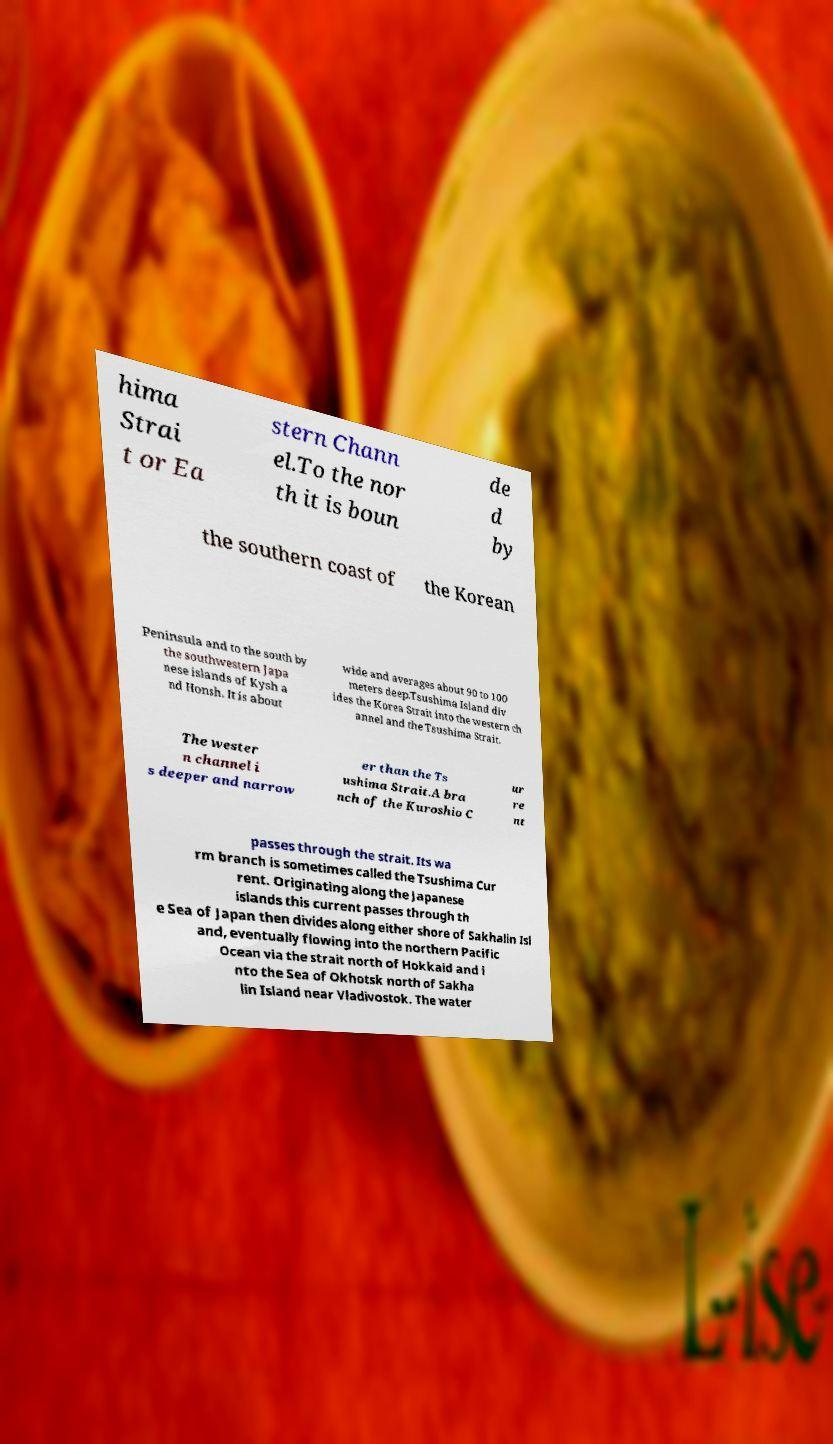Please identify and transcribe the text found in this image. hima Strai t or Ea stern Chann el.To the nor th it is boun de d by the southern coast of the Korean Peninsula and to the south by the southwestern Japa nese islands of Kysh a nd Honsh. It is about wide and averages about 90 to 100 meters deep.Tsushima Island div ides the Korea Strait into the western ch annel and the Tsushima Strait. The wester n channel i s deeper and narrow er than the Ts ushima Strait.A bra nch of the Kuroshio C ur re nt passes through the strait. Its wa rm branch is sometimes called the Tsushima Cur rent. Originating along the Japanese islands this current passes through th e Sea of Japan then divides along either shore of Sakhalin Isl and, eventually flowing into the northern Pacific Ocean via the strait north of Hokkaid and i nto the Sea of Okhotsk north of Sakha lin Island near Vladivostok. The water 